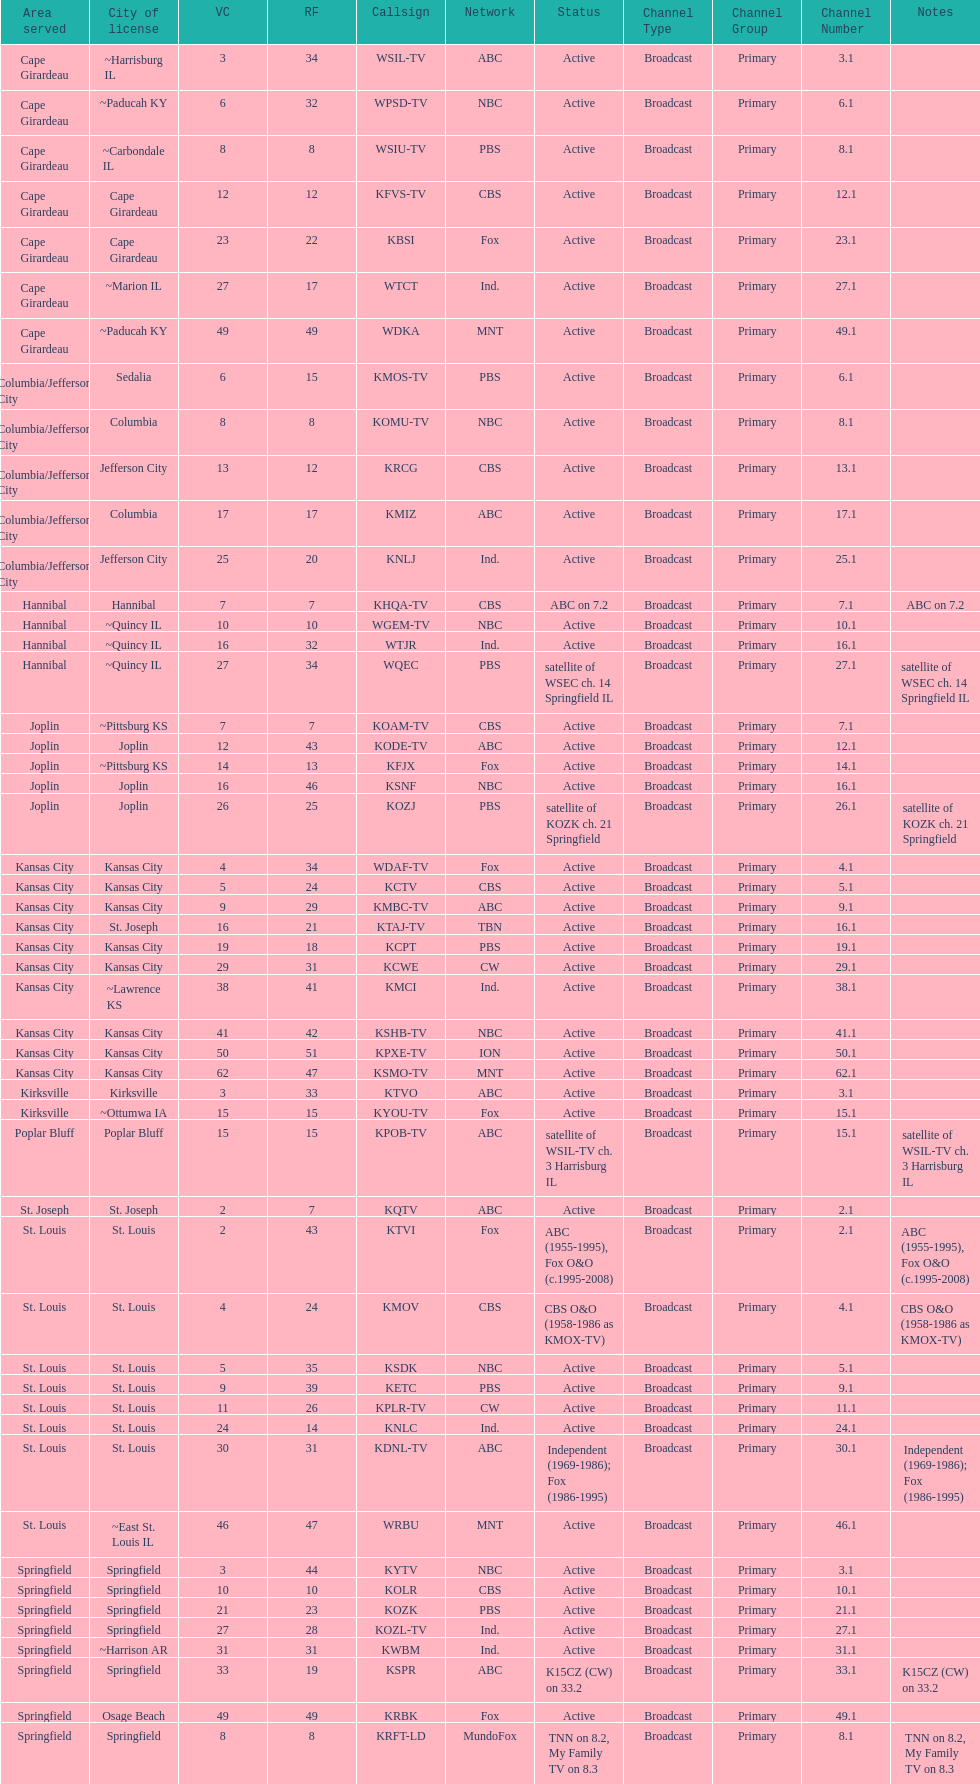How many are on the cbs network? 7. 